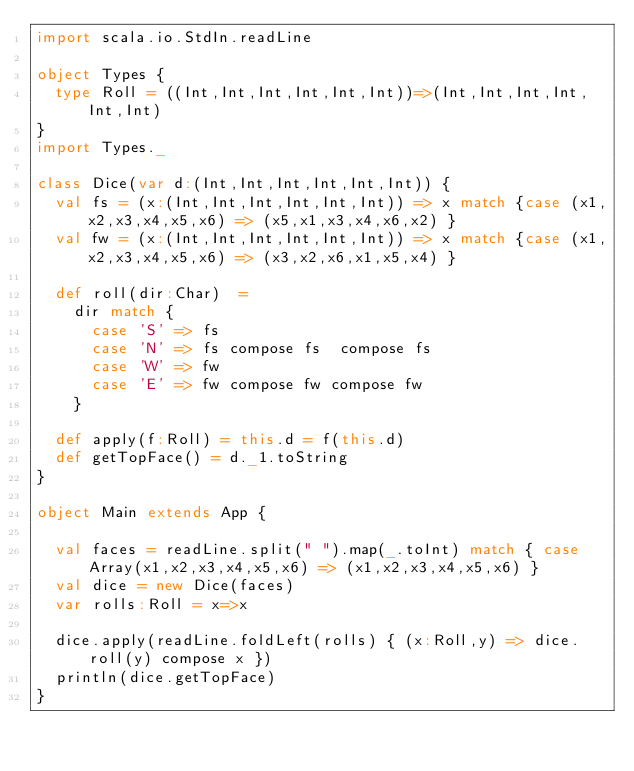Convert code to text. <code><loc_0><loc_0><loc_500><loc_500><_Scala_>import scala.io.StdIn.readLine

object Types {
  type Roll = ((Int,Int,Int,Int,Int,Int))=>(Int,Int,Int,Int,Int,Int)
}
import Types._

class Dice(var d:(Int,Int,Int,Int,Int,Int)) {
  val fs = (x:(Int,Int,Int,Int,Int,Int)) => x match {case (x1,x2,x3,x4,x5,x6) => (x5,x1,x3,x4,x6,x2) }
  val fw = (x:(Int,Int,Int,Int,Int,Int)) => x match {case (x1,x2,x3,x4,x5,x6) => (x3,x2,x6,x1,x5,x4) }

  def roll(dir:Char)  =
    dir match {
      case 'S' => fs
      case 'N' => fs compose fs  compose fs
      case 'W' => fw
      case 'E' => fw compose fw compose fw
    }

  def apply(f:Roll) = this.d = f(this.d)
  def getTopFace() = d._1.toString
}

object Main extends App {

  val faces = readLine.split(" ").map(_.toInt) match { case Array(x1,x2,x3,x4,x5,x6) => (x1,x2,x3,x4,x5,x6) }
  val dice = new Dice(faces)
  var rolls:Roll = x=>x

  dice.apply(readLine.foldLeft(rolls) { (x:Roll,y) => dice.roll(y) compose x })
  println(dice.getTopFace)
}</code> 